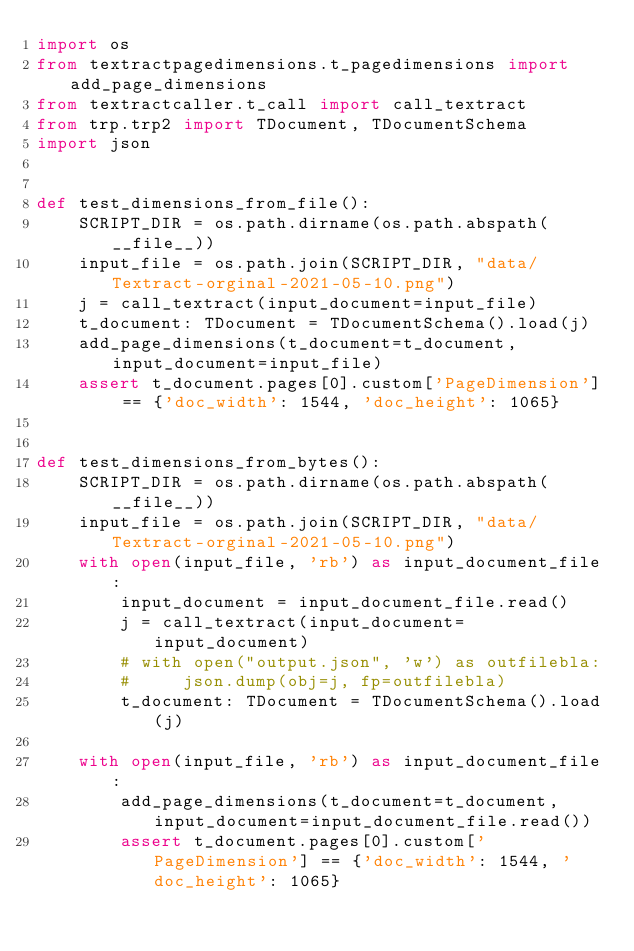Convert code to text. <code><loc_0><loc_0><loc_500><loc_500><_Python_>import os
from textractpagedimensions.t_pagedimensions import add_page_dimensions
from textractcaller.t_call import call_textract
from trp.trp2 import TDocument, TDocumentSchema
import json


def test_dimensions_from_file():
    SCRIPT_DIR = os.path.dirname(os.path.abspath(__file__))
    input_file = os.path.join(SCRIPT_DIR, "data/Textract-orginal-2021-05-10.png")
    j = call_textract(input_document=input_file)
    t_document: TDocument = TDocumentSchema().load(j)
    add_page_dimensions(t_document=t_document, input_document=input_file)
    assert t_document.pages[0].custom['PageDimension'] == {'doc_width': 1544, 'doc_height': 1065}


def test_dimensions_from_bytes():
    SCRIPT_DIR = os.path.dirname(os.path.abspath(__file__))
    input_file = os.path.join(SCRIPT_DIR, "data/Textract-orginal-2021-05-10.png")
    with open(input_file, 'rb') as input_document_file:
        input_document = input_document_file.read()
        j = call_textract(input_document=input_document)
        # with open("output.json", 'w') as outfilebla:
        #     json.dump(obj=j, fp=outfilebla)
        t_document: TDocument = TDocumentSchema().load(j)

    with open(input_file, 'rb') as input_document_file:
        add_page_dimensions(t_document=t_document, input_document=input_document_file.read())
        assert t_document.pages[0].custom['PageDimension'] == {'doc_width': 1544, 'doc_height': 1065}
</code> 